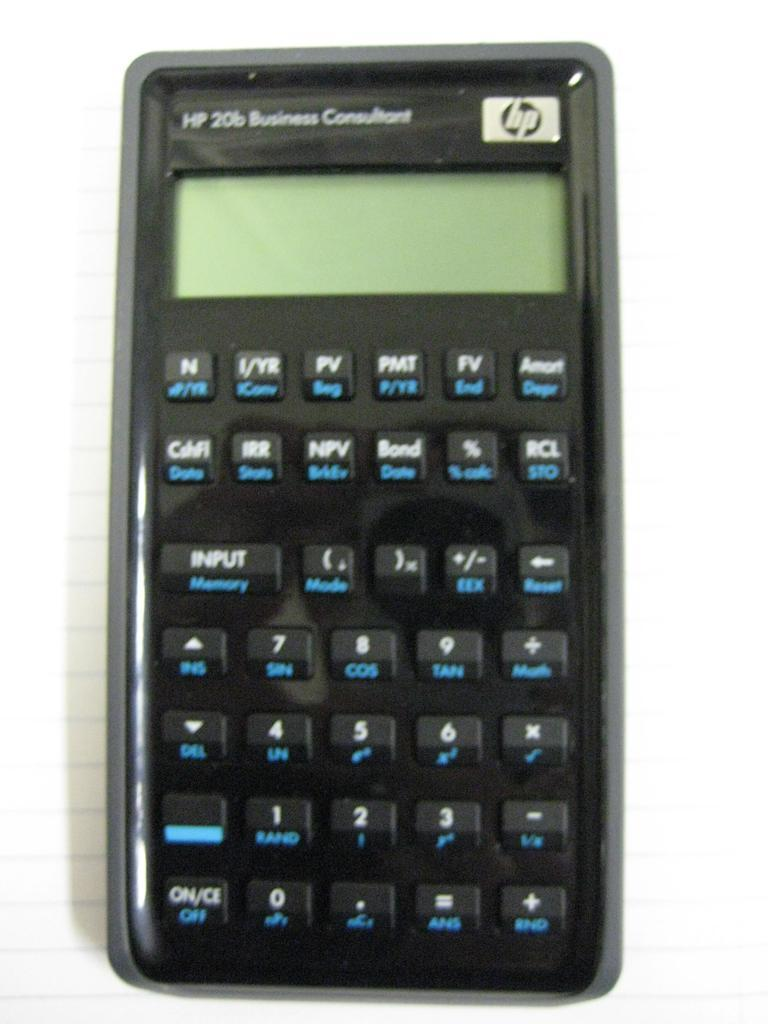Provide a one-sentence caption for the provided image. An Hp 20b Business Consultant calculator sits on top of a sheet of lined paper. 